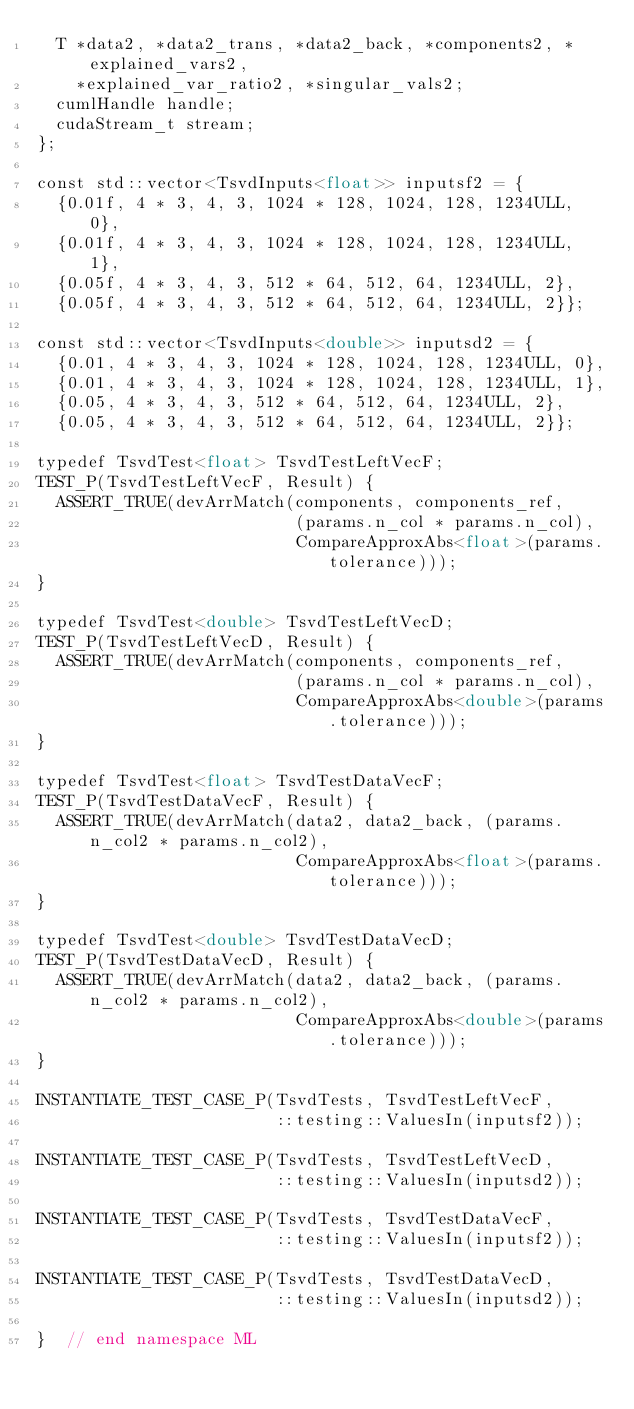<code> <loc_0><loc_0><loc_500><loc_500><_Cuda_>  T *data2, *data2_trans, *data2_back, *components2, *explained_vars2,
    *explained_var_ratio2, *singular_vals2;
  cumlHandle handle;
  cudaStream_t stream;
};

const std::vector<TsvdInputs<float>> inputsf2 = {
  {0.01f, 4 * 3, 4, 3, 1024 * 128, 1024, 128, 1234ULL, 0},
  {0.01f, 4 * 3, 4, 3, 1024 * 128, 1024, 128, 1234ULL, 1},
  {0.05f, 4 * 3, 4, 3, 512 * 64, 512, 64, 1234ULL, 2},
  {0.05f, 4 * 3, 4, 3, 512 * 64, 512, 64, 1234ULL, 2}};

const std::vector<TsvdInputs<double>> inputsd2 = {
  {0.01, 4 * 3, 4, 3, 1024 * 128, 1024, 128, 1234ULL, 0},
  {0.01, 4 * 3, 4, 3, 1024 * 128, 1024, 128, 1234ULL, 1},
  {0.05, 4 * 3, 4, 3, 512 * 64, 512, 64, 1234ULL, 2},
  {0.05, 4 * 3, 4, 3, 512 * 64, 512, 64, 1234ULL, 2}};

typedef TsvdTest<float> TsvdTestLeftVecF;
TEST_P(TsvdTestLeftVecF, Result) {
  ASSERT_TRUE(devArrMatch(components, components_ref,
                          (params.n_col * params.n_col),
                          CompareApproxAbs<float>(params.tolerance)));
}

typedef TsvdTest<double> TsvdTestLeftVecD;
TEST_P(TsvdTestLeftVecD, Result) {
  ASSERT_TRUE(devArrMatch(components, components_ref,
                          (params.n_col * params.n_col),
                          CompareApproxAbs<double>(params.tolerance)));
}

typedef TsvdTest<float> TsvdTestDataVecF;
TEST_P(TsvdTestDataVecF, Result) {
  ASSERT_TRUE(devArrMatch(data2, data2_back, (params.n_col2 * params.n_col2),
                          CompareApproxAbs<float>(params.tolerance)));
}

typedef TsvdTest<double> TsvdTestDataVecD;
TEST_P(TsvdTestDataVecD, Result) {
  ASSERT_TRUE(devArrMatch(data2, data2_back, (params.n_col2 * params.n_col2),
                          CompareApproxAbs<double>(params.tolerance)));
}

INSTANTIATE_TEST_CASE_P(TsvdTests, TsvdTestLeftVecF,
                        ::testing::ValuesIn(inputsf2));

INSTANTIATE_TEST_CASE_P(TsvdTests, TsvdTestLeftVecD,
                        ::testing::ValuesIn(inputsd2));

INSTANTIATE_TEST_CASE_P(TsvdTests, TsvdTestDataVecF,
                        ::testing::ValuesIn(inputsf2));

INSTANTIATE_TEST_CASE_P(TsvdTests, TsvdTestDataVecD,
                        ::testing::ValuesIn(inputsd2));

}  // end namespace ML
</code> 